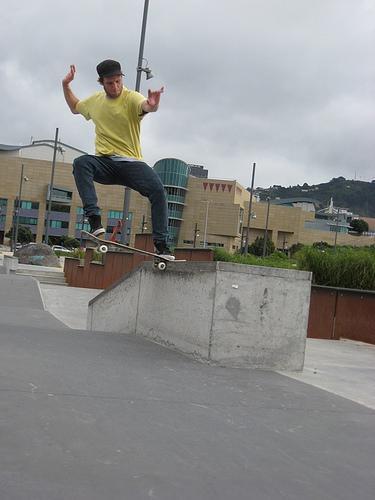How many boats are there?
Give a very brief answer. 0. 